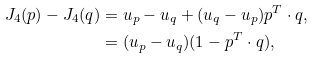<formula> <loc_0><loc_0><loc_500><loc_500>J _ { 4 } ( p ) - J _ { 4 } ( q ) & = u _ { p } - u _ { q } + ( u _ { q } - u _ { p } ) p ^ { T } \cdot q , \\ & = ( u _ { p } - u _ { q } ) ( 1 - p ^ { T } \cdot q ) ,</formula> 